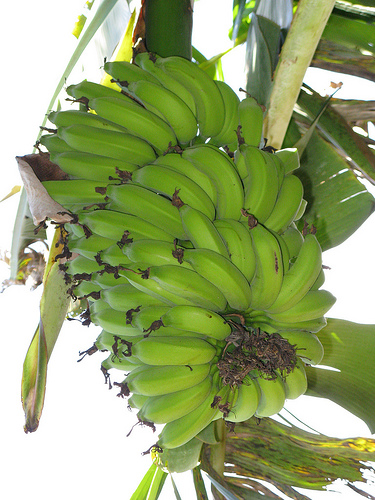<image>
Is the banana on the banana tree? Yes. Looking at the image, I can see the banana is positioned on top of the banana tree, with the banana tree providing support. 